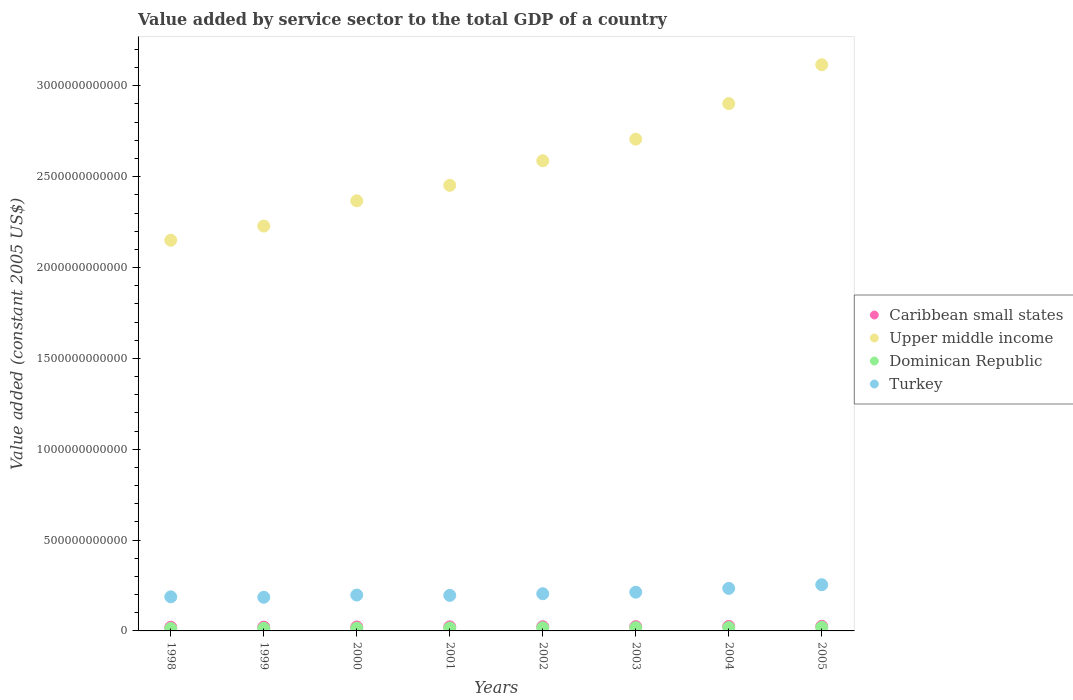How many different coloured dotlines are there?
Your answer should be very brief. 4. Is the number of dotlines equal to the number of legend labels?
Make the answer very short. Yes. What is the value added by service sector in Dominican Republic in 2004?
Your response must be concise. 1.81e+1. Across all years, what is the maximum value added by service sector in Dominican Republic?
Offer a very short reply. 1.97e+1. Across all years, what is the minimum value added by service sector in Upper middle income?
Your response must be concise. 2.15e+12. What is the total value added by service sector in Caribbean small states in the graph?
Make the answer very short. 1.82e+11. What is the difference between the value added by service sector in Turkey in 2001 and that in 2003?
Give a very brief answer. -1.76e+1. What is the difference between the value added by service sector in Upper middle income in 2005 and the value added by service sector in Turkey in 2000?
Provide a succinct answer. 2.92e+12. What is the average value added by service sector in Dominican Republic per year?
Give a very brief answer. 1.63e+1. In the year 2002, what is the difference between the value added by service sector in Turkey and value added by service sector in Upper middle income?
Keep it short and to the point. -2.38e+12. In how many years, is the value added by service sector in Dominican Republic greater than 2500000000000 US$?
Provide a short and direct response. 0. What is the ratio of the value added by service sector in Dominican Republic in 2000 to that in 2004?
Ensure brevity in your answer.  0.82. Is the value added by service sector in Turkey in 1998 less than that in 1999?
Make the answer very short. No. What is the difference between the highest and the second highest value added by service sector in Upper middle income?
Keep it short and to the point. 2.14e+11. What is the difference between the highest and the lowest value added by service sector in Turkey?
Give a very brief answer. 6.90e+1. Is the sum of the value added by service sector in Dominican Republic in 2000 and 2003 greater than the maximum value added by service sector in Turkey across all years?
Your answer should be compact. No. Is it the case that in every year, the sum of the value added by service sector in Dominican Republic and value added by service sector in Turkey  is greater than the value added by service sector in Caribbean small states?
Your response must be concise. Yes. Is the value added by service sector in Dominican Republic strictly greater than the value added by service sector in Caribbean small states over the years?
Your response must be concise. No. Is the value added by service sector in Turkey strictly less than the value added by service sector in Dominican Republic over the years?
Provide a short and direct response. No. What is the difference between two consecutive major ticks on the Y-axis?
Your answer should be compact. 5.00e+11. Are the values on the major ticks of Y-axis written in scientific E-notation?
Ensure brevity in your answer.  No. Does the graph contain any zero values?
Make the answer very short. No. How are the legend labels stacked?
Your answer should be very brief. Vertical. What is the title of the graph?
Offer a very short reply. Value added by service sector to the total GDP of a country. What is the label or title of the Y-axis?
Offer a terse response. Value added (constant 2005 US$). What is the Value added (constant 2005 US$) in Caribbean small states in 1998?
Offer a terse response. 2.03e+1. What is the Value added (constant 2005 US$) in Upper middle income in 1998?
Offer a very short reply. 2.15e+12. What is the Value added (constant 2005 US$) in Dominican Republic in 1998?
Make the answer very short. 1.33e+1. What is the Value added (constant 2005 US$) in Turkey in 1998?
Provide a succinct answer. 1.88e+11. What is the Value added (constant 2005 US$) of Caribbean small states in 1999?
Make the answer very short. 2.11e+1. What is the Value added (constant 2005 US$) of Upper middle income in 1999?
Make the answer very short. 2.23e+12. What is the Value added (constant 2005 US$) in Dominican Republic in 1999?
Keep it short and to the point. 1.42e+1. What is the Value added (constant 2005 US$) in Turkey in 1999?
Offer a terse response. 1.85e+11. What is the Value added (constant 2005 US$) in Caribbean small states in 2000?
Offer a terse response. 2.18e+1. What is the Value added (constant 2005 US$) of Upper middle income in 2000?
Make the answer very short. 2.37e+12. What is the Value added (constant 2005 US$) of Dominican Republic in 2000?
Provide a short and direct response. 1.49e+1. What is the Value added (constant 2005 US$) in Turkey in 2000?
Offer a very short reply. 1.97e+11. What is the Value added (constant 2005 US$) of Caribbean small states in 2001?
Offer a terse response. 2.23e+1. What is the Value added (constant 2005 US$) in Upper middle income in 2001?
Offer a very short reply. 2.45e+12. What is the Value added (constant 2005 US$) in Dominican Republic in 2001?
Keep it short and to the point. 1.58e+1. What is the Value added (constant 2005 US$) in Turkey in 2001?
Ensure brevity in your answer.  1.96e+11. What is the Value added (constant 2005 US$) in Caribbean small states in 2002?
Your answer should be compact. 2.31e+1. What is the Value added (constant 2005 US$) of Upper middle income in 2002?
Keep it short and to the point. 2.59e+12. What is the Value added (constant 2005 US$) in Dominican Republic in 2002?
Your answer should be very brief. 1.70e+1. What is the Value added (constant 2005 US$) in Turkey in 2002?
Give a very brief answer. 2.05e+11. What is the Value added (constant 2005 US$) in Caribbean small states in 2003?
Offer a terse response. 2.36e+1. What is the Value added (constant 2005 US$) in Upper middle income in 2003?
Your response must be concise. 2.71e+12. What is the Value added (constant 2005 US$) in Dominican Republic in 2003?
Keep it short and to the point. 1.77e+1. What is the Value added (constant 2005 US$) in Turkey in 2003?
Provide a short and direct response. 2.13e+11. What is the Value added (constant 2005 US$) of Caribbean small states in 2004?
Your response must be concise. 2.48e+1. What is the Value added (constant 2005 US$) in Upper middle income in 2004?
Ensure brevity in your answer.  2.90e+12. What is the Value added (constant 2005 US$) in Dominican Republic in 2004?
Provide a short and direct response. 1.81e+1. What is the Value added (constant 2005 US$) in Turkey in 2004?
Provide a short and direct response. 2.34e+11. What is the Value added (constant 2005 US$) in Caribbean small states in 2005?
Your answer should be compact. 2.53e+1. What is the Value added (constant 2005 US$) in Upper middle income in 2005?
Make the answer very short. 3.12e+12. What is the Value added (constant 2005 US$) of Dominican Republic in 2005?
Give a very brief answer. 1.97e+1. What is the Value added (constant 2005 US$) in Turkey in 2005?
Your answer should be compact. 2.54e+11. Across all years, what is the maximum Value added (constant 2005 US$) of Caribbean small states?
Offer a very short reply. 2.53e+1. Across all years, what is the maximum Value added (constant 2005 US$) in Upper middle income?
Ensure brevity in your answer.  3.12e+12. Across all years, what is the maximum Value added (constant 2005 US$) of Dominican Republic?
Your answer should be compact. 1.97e+1. Across all years, what is the maximum Value added (constant 2005 US$) in Turkey?
Ensure brevity in your answer.  2.54e+11. Across all years, what is the minimum Value added (constant 2005 US$) in Caribbean small states?
Your response must be concise. 2.03e+1. Across all years, what is the minimum Value added (constant 2005 US$) in Upper middle income?
Give a very brief answer. 2.15e+12. Across all years, what is the minimum Value added (constant 2005 US$) of Dominican Republic?
Provide a succinct answer. 1.33e+1. Across all years, what is the minimum Value added (constant 2005 US$) in Turkey?
Make the answer very short. 1.85e+11. What is the total Value added (constant 2005 US$) in Caribbean small states in the graph?
Your answer should be compact. 1.82e+11. What is the total Value added (constant 2005 US$) in Upper middle income in the graph?
Keep it short and to the point. 2.05e+13. What is the total Value added (constant 2005 US$) of Dominican Republic in the graph?
Ensure brevity in your answer.  1.31e+11. What is the total Value added (constant 2005 US$) of Turkey in the graph?
Give a very brief answer. 1.67e+12. What is the difference between the Value added (constant 2005 US$) of Caribbean small states in 1998 and that in 1999?
Provide a short and direct response. -8.02e+08. What is the difference between the Value added (constant 2005 US$) of Upper middle income in 1998 and that in 1999?
Provide a short and direct response. -7.80e+1. What is the difference between the Value added (constant 2005 US$) of Dominican Republic in 1998 and that in 1999?
Give a very brief answer. -8.99e+08. What is the difference between the Value added (constant 2005 US$) of Turkey in 1998 and that in 1999?
Provide a short and direct response. 2.40e+09. What is the difference between the Value added (constant 2005 US$) in Caribbean small states in 1998 and that in 2000?
Give a very brief answer. -1.56e+09. What is the difference between the Value added (constant 2005 US$) of Upper middle income in 1998 and that in 2000?
Ensure brevity in your answer.  -2.17e+11. What is the difference between the Value added (constant 2005 US$) of Dominican Republic in 1998 and that in 2000?
Offer a very short reply. -1.66e+09. What is the difference between the Value added (constant 2005 US$) of Turkey in 1998 and that in 2000?
Provide a short and direct response. -9.85e+09. What is the difference between the Value added (constant 2005 US$) in Caribbean small states in 1998 and that in 2001?
Offer a very short reply. -2.09e+09. What is the difference between the Value added (constant 2005 US$) in Upper middle income in 1998 and that in 2001?
Provide a succinct answer. -3.02e+11. What is the difference between the Value added (constant 2005 US$) in Dominican Republic in 1998 and that in 2001?
Your answer should be very brief. -2.53e+09. What is the difference between the Value added (constant 2005 US$) in Turkey in 1998 and that in 2001?
Make the answer very short. -7.94e+09. What is the difference between the Value added (constant 2005 US$) of Caribbean small states in 1998 and that in 2002?
Give a very brief answer. -2.87e+09. What is the difference between the Value added (constant 2005 US$) in Upper middle income in 1998 and that in 2002?
Keep it short and to the point. -4.37e+11. What is the difference between the Value added (constant 2005 US$) of Dominican Republic in 1998 and that in 2002?
Provide a short and direct response. -3.71e+09. What is the difference between the Value added (constant 2005 US$) of Turkey in 1998 and that in 2002?
Provide a succinct answer. -1.71e+1. What is the difference between the Value added (constant 2005 US$) in Caribbean small states in 1998 and that in 2003?
Ensure brevity in your answer.  -3.31e+09. What is the difference between the Value added (constant 2005 US$) in Upper middle income in 1998 and that in 2003?
Offer a very short reply. -5.56e+11. What is the difference between the Value added (constant 2005 US$) of Dominican Republic in 1998 and that in 2003?
Provide a short and direct response. -4.40e+09. What is the difference between the Value added (constant 2005 US$) of Turkey in 1998 and that in 2003?
Your response must be concise. -2.55e+1. What is the difference between the Value added (constant 2005 US$) in Caribbean small states in 1998 and that in 2004?
Your response must be concise. -4.55e+09. What is the difference between the Value added (constant 2005 US$) in Upper middle income in 1998 and that in 2004?
Your answer should be very brief. -7.52e+11. What is the difference between the Value added (constant 2005 US$) in Dominican Republic in 1998 and that in 2004?
Your response must be concise. -4.88e+09. What is the difference between the Value added (constant 2005 US$) of Turkey in 1998 and that in 2004?
Your response must be concise. -4.65e+1. What is the difference between the Value added (constant 2005 US$) of Caribbean small states in 1998 and that in 2005?
Make the answer very short. -5.08e+09. What is the difference between the Value added (constant 2005 US$) in Upper middle income in 1998 and that in 2005?
Your answer should be compact. -9.66e+11. What is the difference between the Value added (constant 2005 US$) in Dominican Republic in 1998 and that in 2005?
Make the answer very short. -6.48e+09. What is the difference between the Value added (constant 2005 US$) of Turkey in 1998 and that in 2005?
Provide a succinct answer. -6.66e+1. What is the difference between the Value added (constant 2005 US$) of Caribbean small states in 1999 and that in 2000?
Make the answer very short. -7.59e+08. What is the difference between the Value added (constant 2005 US$) in Upper middle income in 1999 and that in 2000?
Offer a very short reply. -1.39e+11. What is the difference between the Value added (constant 2005 US$) of Dominican Republic in 1999 and that in 2000?
Ensure brevity in your answer.  -7.59e+08. What is the difference between the Value added (constant 2005 US$) of Turkey in 1999 and that in 2000?
Provide a short and direct response. -1.22e+1. What is the difference between the Value added (constant 2005 US$) in Caribbean small states in 1999 and that in 2001?
Provide a succinct answer. -1.29e+09. What is the difference between the Value added (constant 2005 US$) in Upper middle income in 1999 and that in 2001?
Ensure brevity in your answer.  -2.24e+11. What is the difference between the Value added (constant 2005 US$) in Dominican Republic in 1999 and that in 2001?
Ensure brevity in your answer.  -1.64e+09. What is the difference between the Value added (constant 2005 US$) of Turkey in 1999 and that in 2001?
Give a very brief answer. -1.03e+1. What is the difference between the Value added (constant 2005 US$) in Caribbean small states in 1999 and that in 2002?
Your answer should be very brief. -2.07e+09. What is the difference between the Value added (constant 2005 US$) in Upper middle income in 1999 and that in 2002?
Your response must be concise. -3.59e+11. What is the difference between the Value added (constant 2005 US$) of Dominican Republic in 1999 and that in 2002?
Offer a very short reply. -2.81e+09. What is the difference between the Value added (constant 2005 US$) in Turkey in 1999 and that in 2002?
Make the answer very short. -1.95e+1. What is the difference between the Value added (constant 2005 US$) of Caribbean small states in 1999 and that in 2003?
Provide a succinct answer. -2.51e+09. What is the difference between the Value added (constant 2005 US$) in Upper middle income in 1999 and that in 2003?
Your answer should be compact. -4.78e+11. What is the difference between the Value added (constant 2005 US$) of Dominican Republic in 1999 and that in 2003?
Offer a very short reply. -3.50e+09. What is the difference between the Value added (constant 2005 US$) in Turkey in 1999 and that in 2003?
Ensure brevity in your answer.  -2.79e+1. What is the difference between the Value added (constant 2005 US$) of Caribbean small states in 1999 and that in 2004?
Offer a very short reply. -3.75e+09. What is the difference between the Value added (constant 2005 US$) of Upper middle income in 1999 and that in 2004?
Your answer should be very brief. -6.74e+11. What is the difference between the Value added (constant 2005 US$) in Dominican Republic in 1999 and that in 2004?
Keep it short and to the point. -3.98e+09. What is the difference between the Value added (constant 2005 US$) of Turkey in 1999 and that in 2004?
Your response must be concise. -4.89e+1. What is the difference between the Value added (constant 2005 US$) in Caribbean small states in 1999 and that in 2005?
Your response must be concise. -4.28e+09. What is the difference between the Value added (constant 2005 US$) in Upper middle income in 1999 and that in 2005?
Provide a short and direct response. -8.88e+11. What is the difference between the Value added (constant 2005 US$) in Dominican Republic in 1999 and that in 2005?
Offer a terse response. -5.58e+09. What is the difference between the Value added (constant 2005 US$) of Turkey in 1999 and that in 2005?
Offer a very short reply. -6.90e+1. What is the difference between the Value added (constant 2005 US$) in Caribbean small states in 2000 and that in 2001?
Make the answer very short. -5.29e+08. What is the difference between the Value added (constant 2005 US$) of Upper middle income in 2000 and that in 2001?
Make the answer very short. -8.53e+1. What is the difference between the Value added (constant 2005 US$) of Dominican Republic in 2000 and that in 2001?
Provide a short and direct response. -8.76e+08. What is the difference between the Value added (constant 2005 US$) of Turkey in 2000 and that in 2001?
Keep it short and to the point. 1.90e+09. What is the difference between the Value added (constant 2005 US$) of Caribbean small states in 2000 and that in 2002?
Ensure brevity in your answer.  -1.31e+09. What is the difference between the Value added (constant 2005 US$) of Upper middle income in 2000 and that in 2002?
Offer a terse response. -2.21e+11. What is the difference between the Value added (constant 2005 US$) of Dominican Republic in 2000 and that in 2002?
Offer a very short reply. -2.06e+09. What is the difference between the Value added (constant 2005 US$) of Turkey in 2000 and that in 2002?
Make the answer very short. -7.24e+09. What is the difference between the Value added (constant 2005 US$) in Caribbean small states in 2000 and that in 2003?
Provide a short and direct response. -1.75e+09. What is the difference between the Value added (constant 2005 US$) of Upper middle income in 2000 and that in 2003?
Offer a terse response. -3.39e+11. What is the difference between the Value added (constant 2005 US$) of Dominican Republic in 2000 and that in 2003?
Provide a short and direct response. -2.74e+09. What is the difference between the Value added (constant 2005 US$) in Turkey in 2000 and that in 2003?
Keep it short and to the point. -1.57e+1. What is the difference between the Value added (constant 2005 US$) in Caribbean small states in 2000 and that in 2004?
Offer a terse response. -2.99e+09. What is the difference between the Value added (constant 2005 US$) in Upper middle income in 2000 and that in 2004?
Give a very brief answer. -5.35e+11. What is the difference between the Value added (constant 2005 US$) of Dominican Republic in 2000 and that in 2004?
Ensure brevity in your answer.  -3.22e+09. What is the difference between the Value added (constant 2005 US$) of Turkey in 2000 and that in 2004?
Provide a short and direct response. -3.67e+1. What is the difference between the Value added (constant 2005 US$) of Caribbean small states in 2000 and that in 2005?
Provide a succinct answer. -3.52e+09. What is the difference between the Value added (constant 2005 US$) of Upper middle income in 2000 and that in 2005?
Make the answer very short. -7.49e+11. What is the difference between the Value added (constant 2005 US$) in Dominican Republic in 2000 and that in 2005?
Provide a short and direct response. -4.82e+09. What is the difference between the Value added (constant 2005 US$) of Turkey in 2000 and that in 2005?
Your response must be concise. -5.68e+1. What is the difference between the Value added (constant 2005 US$) in Caribbean small states in 2001 and that in 2002?
Provide a short and direct response. -7.84e+08. What is the difference between the Value added (constant 2005 US$) of Upper middle income in 2001 and that in 2002?
Make the answer very short. -1.35e+11. What is the difference between the Value added (constant 2005 US$) in Dominican Republic in 2001 and that in 2002?
Offer a terse response. -1.18e+09. What is the difference between the Value added (constant 2005 US$) of Turkey in 2001 and that in 2002?
Keep it short and to the point. -9.14e+09. What is the difference between the Value added (constant 2005 US$) of Caribbean small states in 2001 and that in 2003?
Offer a very short reply. -1.22e+09. What is the difference between the Value added (constant 2005 US$) in Upper middle income in 2001 and that in 2003?
Provide a succinct answer. -2.54e+11. What is the difference between the Value added (constant 2005 US$) of Dominican Republic in 2001 and that in 2003?
Your answer should be very brief. -1.86e+09. What is the difference between the Value added (constant 2005 US$) of Turkey in 2001 and that in 2003?
Your answer should be compact. -1.76e+1. What is the difference between the Value added (constant 2005 US$) of Caribbean small states in 2001 and that in 2004?
Offer a terse response. -2.46e+09. What is the difference between the Value added (constant 2005 US$) in Upper middle income in 2001 and that in 2004?
Provide a short and direct response. -4.50e+11. What is the difference between the Value added (constant 2005 US$) of Dominican Republic in 2001 and that in 2004?
Make the answer very short. -2.34e+09. What is the difference between the Value added (constant 2005 US$) of Turkey in 2001 and that in 2004?
Give a very brief answer. -3.86e+1. What is the difference between the Value added (constant 2005 US$) in Caribbean small states in 2001 and that in 2005?
Offer a very short reply. -3.00e+09. What is the difference between the Value added (constant 2005 US$) of Upper middle income in 2001 and that in 2005?
Offer a terse response. -6.64e+11. What is the difference between the Value added (constant 2005 US$) of Dominican Republic in 2001 and that in 2005?
Make the answer very short. -3.94e+09. What is the difference between the Value added (constant 2005 US$) of Turkey in 2001 and that in 2005?
Provide a succinct answer. -5.87e+1. What is the difference between the Value added (constant 2005 US$) of Caribbean small states in 2002 and that in 2003?
Your answer should be very brief. -4.38e+08. What is the difference between the Value added (constant 2005 US$) of Upper middle income in 2002 and that in 2003?
Your answer should be compact. -1.19e+11. What is the difference between the Value added (constant 2005 US$) of Dominican Republic in 2002 and that in 2003?
Make the answer very short. -6.85e+08. What is the difference between the Value added (constant 2005 US$) in Turkey in 2002 and that in 2003?
Your answer should be very brief. -8.46e+09. What is the difference between the Value added (constant 2005 US$) in Caribbean small states in 2002 and that in 2004?
Give a very brief answer. -1.68e+09. What is the difference between the Value added (constant 2005 US$) of Upper middle income in 2002 and that in 2004?
Ensure brevity in your answer.  -3.15e+11. What is the difference between the Value added (constant 2005 US$) of Dominican Republic in 2002 and that in 2004?
Your answer should be very brief. -1.16e+09. What is the difference between the Value added (constant 2005 US$) in Turkey in 2002 and that in 2004?
Ensure brevity in your answer.  -2.94e+1. What is the difference between the Value added (constant 2005 US$) of Caribbean small states in 2002 and that in 2005?
Give a very brief answer. -2.21e+09. What is the difference between the Value added (constant 2005 US$) of Upper middle income in 2002 and that in 2005?
Ensure brevity in your answer.  -5.28e+11. What is the difference between the Value added (constant 2005 US$) of Dominican Republic in 2002 and that in 2005?
Provide a short and direct response. -2.76e+09. What is the difference between the Value added (constant 2005 US$) of Turkey in 2002 and that in 2005?
Keep it short and to the point. -4.95e+1. What is the difference between the Value added (constant 2005 US$) of Caribbean small states in 2003 and that in 2004?
Your response must be concise. -1.24e+09. What is the difference between the Value added (constant 2005 US$) of Upper middle income in 2003 and that in 2004?
Make the answer very short. -1.96e+11. What is the difference between the Value added (constant 2005 US$) in Dominican Republic in 2003 and that in 2004?
Keep it short and to the point. -4.76e+08. What is the difference between the Value added (constant 2005 US$) in Turkey in 2003 and that in 2004?
Your answer should be very brief. -2.10e+1. What is the difference between the Value added (constant 2005 US$) of Caribbean small states in 2003 and that in 2005?
Offer a terse response. -1.77e+09. What is the difference between the Value added (constant 2005 US$) of Upper middle income in 2003 and that in 2005?
Ensure brevity in your answer.  -4.09e+11. What is the difference between the Value added (constant 2005 US$) in Dominican Republic in 2003 and that in 2005?
Ensure brevity in your answer.  -2.08e+09. What is the difference between the Value added (constant 2005 US$) of Turkey in 2003 and that in 2005?
Your response must be concise. -4.11e+1. What is the difference between the Value added (constant 2005 US$) in Caribbean small states in 2004 and that in 2005?
Provide a short and direct response. -5.33e+08. What is the difference between the Value added (constant 2005 US$) in Upper middle income in 2004 and that in 2005?
Your answer should be compact. -2.14e+11. What is the difference between the Value added (constant 2005 US$) of Dominican Republic in 2004 and that in 2005?
Offer a terse response. -1.60e+09. What is the difference between the Value added (constant 2005 US$) in Turkey in 2004 and that in 2005?
Your response must be concise. -2.01e+1. What is the difference between the Value added (constant 2005 US$) in Caribbean small states in 1998 and the Value added (constant 2005 US$) in Upper middle income in 1999?
Offer a very short reply. -2.21e+12. What is the difference between the Value added (constant 2005 US$) in Caribbean small states in 1998 and the Value added (constant 2005 US$) in Dominican Republic in 1999?
Ensure brevity in your answer.  6.09e+09. What is the difference between the Value added (constant 2005 US$) of Caribbean small states in 1998 and the Value added (constant 2005 US$) of Turkey in 1999?
Offer a very short reply. -1.65e+11. What is the difference between the Value added (constant 2005 US$) of Upper middle income in 1998 and the Value added (constant 2005 US$) of Dominican Republic in 1999?
Provide a succinct answer. 2.14e+12. What is the difference between the Value added (constant 2005 US$) in Upper middle income in 1998 and the Value added (constant 2005 US$) in Turkey in 1999?
Make the answer very short. 1.96e+12. What is the difference between the Value added (constant 2005 US$) in Dominican Republic in 1998 and the Value added (constant 2005 US$) in Turkey in 1999?
Ensure brevity in your answer.  -1.72e+11. What is the difference between the Value added (constant 2005 US$) in Caribbean small states in 1998 and the Value added (constant 2005 US$) in Upper middle income in 2000?
Make the answer very short. -2.35e+12. What is the difference between the Value added (constant 2005 US$) of Caribbean small states in 1998 and the Value added (constant 2005 US$) of Dominican Republic in 2000?
Provide a short and direct response. 5.33e+09. What is the difference between the Value added (constant 2005 US$) of Caribbean small states in 1998 and the Value added (constant 2005 US$) of Turkey in 2000?
Ensure brevity in your answer.  -1.77e+11. What is the difference between the Value added (constant 2005 US$) in Upper middle income in 1998 and the Value added (constant 2005 US$) in Dominican Republic in 2000?
Keep it short and to the point. 2.14e+12. What is the difference between the Value added (constant 2005 US$) in Upper middle income in 1998 and the Value added (constant 2005 US$) in Turkey in 2000?
Give a very brief answer. 1.95e+12. What is the difference between the Value added (constant 2005 US$) of Dominican Republic in 1998 and the Value added (constant 2005 US$) of Turkey in 2000?
Provide a succinct answer. -1.84e+11. What is the difference between the Value added (constant 2005 US$) in Caribbean small states in 1998 and the Value added (constant 2005 US$) in Upper middle income in 2001?
Keep it short and to the point. -2.43e+12. What is the difference between the Value added (constant 2005 US$) in Caribbean small states in 1998 and the Value added (constant 2005 US$) in Dominican Republic in 2001?
Ensure brevity in your answer.  4.45e+09. What is the difference between the Value added (constant 2005 US$) of Caribbean small states in 1998 and the Value added (constant 2005 US$) of Turkey in 2001?
Your response must be concise. -1.75e+11. What is the difference between the Value added (constant 2005 US$) of Upper middle income in 1998 and the Value added (constant 2005 US$) of Dominican Republic in 2001?
Make the answer very short. 2.13e+12. What is the difference between the Value added (constant 2005 US$) in Upper middle income in 1998 and the Value added (constant 2005 US$) in Turkey in 2001?
Offer a very short reply. 1.95e+12. What is the difference between the Value added (constant 2005 US$) in Dominican Republic in 1998 and the Value added (constant 2005 US$) in Turkey in 2001?
Your response must be concise. -1.82e+11. What is the difference between the Value added (constant 2005 US$) in Caribbean small states in 1998 and the Value added (constant 2005 US$) in Upper middle income in 2002?
Make the answer very short. -2.57e+12. What is the difference between the Value added (constant 2005 US$) of Caribbean small states in 1998 and the Value added (constant 2005 US$) of Dominican Republic in 2002?
Your answer should be compact. 3.27e+09. What is the difference between the Value added (constant 2005 US$) of Caribbean small states in 1998 and the Value added (constant 2005 US$) of Turkey in 2002?
Offer a terse response. -1.84e+11. What is the difference between the Value added (constant 2005 US$) of Upper middle income in 1998 and the Value added (constant 2005 US$) of Dominican Republic in 2002?
Offer a very short reply. 2.13e+12. What is the difference between the Value added (constant 2005 US$) in Upper middle income in 1998 and the Value added (constant 2005 US$) in Turkey in 2002?
Your answer should be very brief. 1.95e+12. What is the difference between the Value added (constant 2005 US$) in Dominican Republic in 1998 and the Value added (constant 2005 US$) in Turkey in 2002?
Make the answer very short. -1.91e+11. What is the difference between the Value added (constant 2005 US$) of Caribbean small states in 1998 and the Value added (constant 2005 US$) of Upper middle income in 2003?
Keep it short and to the point. -2.69e+12. What is the difference between the Value added (constant 2005 US$) in Caribbean small states in 1998 and the Value added (constant 2005 US$) in Dominican Republic in 2003?
Keep it short and to the point. 2.59e+09. What is the difference between the Value added (constant 2005 US$) in Caribbean small states in 1998 and the Value added (constant 2005 US$) in Turkey in 2003?
Keep it short and to the point. -1.93e+11. What is the difference between the Value added (constant 2005 US$) in Upper middle income in 1998 and the Value added (constant 2005 US$) in Dominican Republic in 2003?
Give a very brief answer. 2.13e+12. What is the difference between the Value added (constant 2005 US$) of Upper middle income in 1998 and the Value added (constant 2005 US$) of Turkey in 2003?
Offer a very short reply. 1.94e+12. What is the difference between the Value added (constant 2005 US$) of Dominican Republic in 1998 and the Value added (constant 2005 US$) of Turkey in 2003?
Give a very brief answer. -2.00e+11. What is the difference between the Value added (constant 2005 US$) in Caribbean small states in 1998 and the Value added (constant 2005 US$) in Upper middle income in 2004?
Provide a succinct answer. -2.88e+12. What is the difference between the Value added (constant 2005 US$) in Caribbean small states in 1998 and the Value added (constant 2005 US$) in Dominican Republic in 2004?
Offer a very short reply. 2.11e+09. What is the difference between the Value added (constant 2005 US$) in Caribbean small states in 1998 and the Value added (constant 2005 US$) in Turkey in 2004?
Offer a terse response. -2.14e+11. What is the difference between the Value added (constant 2005 US$) in Upper middle income in 1998 and the Value added (constant 2005 US$) in Dominican Republic in 2004?
Offer a very short reply. 2.13e+12. What is the difference between the Value added (constant 2005 US$) in Upper middle income in 1998 and the Value added (constant 2005 US$) in Turkey in 2004?
Ensure brevity in your answer.  1.92e+12. What is the difference between the Value added (constant 2005 US$) of Dominican Republic in 1998 and the Value added (constant 2005 US$) of Turkey in 2004?
Provide a short and direct response. -2.21e+11. What is the difference between the Value added (constant 2005 US$) of Caribbean small states in 1998 and the Value added (constant 2005 US$) of Upper middle income in 2005?
Provide a short and direct response. -3.10e+12. What is the difference between the Value added (constant 2005 US$) in Caribbean small states in 1998 and the Value added (constant 2005 US$) in Dominican Republic in 2005?
Your response must be concise. 5.11e+08. What is the difference between the Value added (constant 2005 US$) in Caribbean small states in 1998 and the Value added (constant 2005 US$) in Turkey in 2005?
Ensure brevity in your answer.  -2.34e+11. What is the difference between the Value added (constant 2005 US$) in Upper middle income in 1998 and the Value added (constant 2005 US$) in Dominican Republic in 2005?
Make the answer very short. 2.13e+12. What is the difference between the Value added (constant 2005 US$) in Upper middle income in 1998 and the Value added (constant 2005 US$) in Turkey in 2005?
Provide a succinct answer. 1.90e+12. What is the difference between the Value added (constant 2005 US$) of Dominican Republic in 1998 and the Value added (constant 2005 US$) of Turkey in 2005?
Your answer should be very brief. -2.41e+11. What is the difference between the Value added (constant 2005 US$) of Caribbean small states in 1999 and the Value added (constant 2005 US$) of Upper middle income in 2000?
Your answer should be compact. -2.35e+12. What is the difference between the Value added (constant 2005 US$) of Caribbean small states in 1999 and the Value added (constant 2005 US$) of Dominican Republic in 2000?
Keep it short and to the point. 6.13e+09. What is the difference between the Value added (constant 2005 US$) of Caribbean small states in 1999 and the Value added (constant 2005 US$) of Turkey in 2000?
Give a very brief answer. -1.76e+11. What is the difference between the Value added (constant 2005 US$) in Upper middle income in 1999 and the Value added (constant 2005 US$) in Dominican Republic in 2000?
Keep it short and to the point. 2.21e+12. What is the difference between the Value added (constant 2005 US$) of Upper middle income in 1999 and the Value added (constant 2005 US$) of Turkey in 2000?
Give a very brief answer. 2.03e+12. What is the difference between the Value added (constant 2005 US$) of Dominican Republic in 1999 and the Value added (constant 2005 US$) of Turkey in 2000?
Keep it short and to the point. -1.83e+11. What is the difference between the Value added (constant 2005 US$) in Caribbean small states in 1999 and the Value added (constant 2005 US$) in Upper middle income in 2001?
Keep it short and to the point. -2.43e+12. What is the difference between the Value added (constant 2005 US$) of Caribbean small states in 1999 and the Value added (constant 2005 US$) of Dominican Republic in 2001?
Your response must be concise. 5.26e+09. What is the difference between the Value added (constant 2005 US$) of Caribbean small states in 1999 and the Value added (constant 2005 US$) of Turkey in 2001?
Provide a succinct answer. -1.75e+11. What is the difference between the Value added (constant 2005 US$) in Upper middle income in 1999 and the Value added (constant 2005 US$) in Dominican Republic in 2001?
Your response must be concise. 2.21e+12. What is the difference between the Value added (constant 2005 US$) in Upper middle income in 1999 and the Value added (constant 2005 US$) in Turkey in 2001?
Provide a short and direct response. 2.03e+12. What is the difference between the Value added (constant 2005 US$) of Dominican Republic in 1999 and the Value added (constant 2005 US$) of Turkey in 2001?
Offer a terse response. -1.81e+11. What is the difference between the Value added (constant 2005 US$) in Caribbean small states in 1999 and the Value added (constant 2005 US$) in Upper middle income in 2002?
Offer a terse response. -2.57e+12. What is the difference between the Value added (constant 2005 US$) of Caribbean small states in 1999 and the Value added (constant 2005 US$) of Dominican Republic in 2002?
Ensure brevity in your answer.  4.08e+09. What is the difference between the Value added (constant 2005 US$) of Caribbean small states in 1999 and the Value added (constant 2005 US$) of Turkey in 2002?
Your answer should be compact. -1.84e+11. What is the difference between the Value added (constant 2005 US$) in Upper middle income in 1999 and the Value added (constant 2005 US$) in Dominican Republic in 2002?
Your response must be concise. 2.21e+12. What is the difference between the Value added (constant 2005 US$) in Upper middle income in 1999 and the Value added (constant 2005 US$) in Turkey in 2002?
Offer a terse response. 2.02e+12. What is the difference between the Value added (constant 2005 US$) in Dominican Republic in 1999 and the Value added (constant 2005 US$) in Turkey in 2002?
Keep it short and to the point. -1.91e+11. What is the difference between the Value added (constant 2005 US$) of Caribbean small states in 1999 and the Value added (constant 2005 US$) of Upper middle income in 2003?
Your answer should be compact. -2.69e+12. What is the difference between the Value added (constant 2005 US$) of Caribbean small states in 1999 and the Value added (constant 2005 US$) of Dominican Republic in 2003?
Give a very brief answer. 3.39e+09. What is the difference between the Value added (constant 2005 US$) of Caribbean small states in 1999 and the Value added (constant 2005 US$) of Turkey in 2003?
Give a very brief answer. -1.92e+11. What is the difference between the Value added (constant 2005 US$) of Upper middle income in 1999 and the Value added (constant 2005 US$) of Dominican Republic in 2003?
Your response must be concise. 2.21e+12. What is the difference between the Value added (constant 2005 US$) of Upper middle income in 1999 and the Value added (constant 2005 US$) of Turkey in 2003?
Your answer should be very brief. 2.02e+12. What is the difference between the Value added (constant 2005 US$) of Dominican Republic in 1999 and the Value added (constant 2005 US$) of Turkey in 2003?
Keep it short and to the point. -1.99e+11. What is the difference between the Value added (constant 2005 US$) of Caribbean small states in 1999 and the Value added (constant 2005 US$) of Upper middle income in 2004?
Your answer should be very brief. -2.88e+12. What is the difference between the Value added (constant 2005 US$) of Caribbean small states in 1999 and the Value added (constant 2005 US$) of Dominican Republic in 2004?
Keep it short and to the point. 2.92e+09. What is the difference between the Value added (constant 2005 US$) of Caribbean small states in 1999 and the Value added (constant 2005 US$) of Turkey in 2004?
Provide a succinct answer. -2.13e+11. What is the difference between the Value added (constant 2005 US$) in Upper middle income in 1999 and the Value added (constant 2005 US$) in Dominican Republic in 2004?
Give a very brief answer. 2.21e+12. What is the difference between the Value added (constant 2005 US$) of Upper middle income in 1999 and the Value added (constant 2005 US$) of Turkey in 2004?
Offer a terse response. 1.99e+12. What is the difference between the Value added (constant 2005 US$) of Dominican Republic in 1999 and the Value added (constant 2005 US$) of Turkey in 2004?
Provide a short and direct response. -2.20e+11. What is the difference between the Value added (constant 2005 US$) of Caribbean small states in 1999 and the Value added (constant 2005 US$) of Upper middle income in 2005?
Keep it short and to the point. -3.09e+12. What is the difference between the Value added (constant 2005 US$) in Caribbean small states in 1999 and the Value added (constant 2005 US$) in Dominican Republic in 2005?
Your answer should be very brief. 1.31e+09. What is the difference between the Value added (constant 2005 US$) of Caribbean small states in 1999 and the Value added (constant 2005 US$) of Turkey in 2005?
Provide a short and direct response. -2.33e+11. What is the difference between the Value added (constant 2005 US$) of Upper middle income in 1999 and the Value added (constant 2005 US$) of Dominican Republic in 2005?
Offer a terse response. 2.21e+12. What is the difference between the Value added (constant 2005 US$) of Upper middle income in 1999 and the Value added (constant 2005 US$) of Turkey in 2005?
Make the answer very short. 1.97e+12. What is the difference between the Value added (constant 2005 US$) in Dominican Republic in 1999 and the Value added (constant 2005 US$) in Turkey in 2005?
Your answer should be compact. -2.40e+11. What is the difference between the Value added (constant 2005 US$) of Caribbean small states in 2000 and the Value added (constant 2005 US$) of Upper middle income in 2001?
Your answer should be very brief. -2.43e+12. What is the difference between the Value added (constant 2005 US$) of Caribbean small states in 2000 and the Value added (constant 2005 US$) of Dominican Republic in 2001?
Ensure brevity in your answer.  6.01e+09. What is the difference between the Value added (constant 2005 US$) of Caribbean small states in 2000 and the Value added (constant 2005 US$) of Turkey in 2001?
Offer a terse response. -1.74e+11. What is the difference between the Value added (constant 2005 US$) in Upper middle income in 2000 and the Value added (constant 2005 US$) in Dominican Republic in 2001?
Your answer should be compact. 2.35e+12. What is the difference between the Value added (constant 2005 US$) in Upper middle income in 2000 and the Value added (constant 2005 US$) in Turkey in 2001?
Your answer should be very brief. 2.17e+12. What is the difference between the Value added (constant 2005 US$) in Dominican Republic in 2000 and the Value added (constant 2005 US$) in Turkey in 2001?
Provide a short and direct response. -1.81e+11. What is the difference between the Value added (constant 2005 US$) of Caribbean small states in 2000 and the Value added (constant 2005 US$) of Upper middle income in 2002?
Keep it short and to the point. -2.57e+12. What is the difference between the Value added (constant 2005 US$) in Caribbean small states in 2000 and the Value added (constant 2005 US$) in Dominican Republic in 2002?
Your answer should be very brief. 4.84e+09. What is the difference between the Value added (constant 2005 US$) of Caribbean small states in 2000 and the Value added (constant 2005 US$) of Turkey in 2002?
Make the answer very short. -1.83e+11. What is the difference between the Value added (constant 2005 US$) of Upper middle income in 2000 and the Value added (constant 2005 US$) of Dominican Republic in 2002?
Provide a short and direct response. 2.35e+12. What is the difference between the Value added (constant 2005 US$) in Upper middle income in 2000 and the Value added (constant 2005 US$) in Turkey in 2002?
Provide a succinct answer. 2.16e+12. What is the difference between the Value added (constant 2005 US$) of Dominican Republic in 2000 and the Value added (constant 2005 US$) of Turkey in 2002?
Keep it short and to the point. -1.90e+11. What is the difference between the Value added (constant 2005 US$) in Caribbean small states in 2000 and the Value added (constant 2005 US$) in Upper middle income in 2003?
Ensure brevity in your answer.  -2.68e+12. What is the difference between the Value added (constant 2005 US$) in Caribbean small states in 2000 and the Value added (constant 2005 US$) in Dominican Republic in 2003?
Make the answer very short. 4.15e+09. What is the difference between the Value added (constant 2005 US$) in Caribbean small states in 2000 and the Value added (constant 2005 US$) in Turkey in 2003?
Your response must be concise. -1.91e+11. What is the difference between the Value added (constant 2005 US$) of Upper middle income in 2000 and the Value added (constant 2005 US$) of Dominican Republic in 2003?
Offer a very short reply. 2.35e+12. What is the difference between the Value added (constant 2005 US$) of Upper middle income in 2000 and the Value added (constant 2005 US$) of Turkey in 2003?
Provide a short and direct response. 2.15e+12. What is the difference between the Value added (constant 2005 US$) of Dominican Republic in 2000 and the Value added (constant 2005 US$) of Turkey in 2003?
Offer a terse response. -1.98e+11. What is the difference between the Value added (constant 2005 US$) in Caribbean small states in 2000 and the Value added (constant 2005 US$) in Upper middle income in 2004?
Your response must be concise. -2.88e+12. What is the difference between the Value added (constant 2005 US$) in Caribbean small states in 2000 and the Value added (constant 2005 US$) in Dominican Republic in 2004?
Your answer should be compact. 3.67e+09. What is the difference between the Value added (constant 2005 US$) in Caribbean small states in 2000 and the Value added (constant 2005 US$) in Turkey in 2004?
Ensure brevity in your answer.  -2.12e+11. What is the difference between the Value added (constant 2005 US$) in Upper middle income in 2000 and the Value added (constant 2005 US$) in Dominican Republic in 2004?
Your answer should be very brief. 2.35e+12. What is the difference between the Value added (constant 2005 US$) of Upper middle income in 2000 and the Value added (constant 2005 US$) of Turkey in 2004?
Your answer should be very brief. 2.13e+12. What is the difference between the Value added (constant 2005 US$) in Dominican Republic in 2000 and the Value added (constant 2005 US$) in Turkey in 2004?
Keep it short and to the point. -2.19e+11. What is the difference between the Value added (constant 2005 US$) of Caribbean small states in 2000 and the Value added (constant 2005 US$) of Upper middle income in 2005?
Your answer should be very brief. -3.09e+12. What is the difference between the Value added (constant 2005 US$) of Caribbean small states in 2000 and the Value added (constant 2005 US$) of Dominican Republic in 2005?
Keep it short and to the point. 2.07e+09. What is the difference between the Value added (constant 2005 US$) in Caribbean small states in 2000 and the Value added (constant 2005 US$) in Turkey in 2005?
Your answer should be compact. -2.32e+11. What is the difference between the Value added (constant 2005 US$) of Upper middle income in 2000 and the Value added (constant 2005 US$) of Dominican Republic in 2005?
Your answer should be very brief. 2.35e+12. What is the difference between the Value added (constant 2005 US$) of Upper middle income in 2000 and the Value added (constant 2005 US$) of Turkey in 2005?
Ensure brevity in your answer.  2.11e+12. What is the difference between the Value added (constant 2005 US$) in Dominican Republic in 2000 and the Value added (constant 2005 US$) in Turkey in 2005?
Provide a succinct answer. -2.39e+11. What is the difference between the Value added (constant 2005 US$) of Caribbean small states in 2001 and the Value added (constant 2005 US$) of Upper middle income in 2002?
Give a very brief answer. -2.57e+12. What is the difference between the Value added (constant 2005 US$) of Caribbean small states in 2001 and the Value added (constant 2005 US$) of Dominican Republic in 2002?
Give a very brief answer. 5.36e+09. What is the difference between the Value added (constant 2005 US$) in Caribbean small states in 2001 and the Value added (constant 2005 US$) in Turkey in 2002?
Make the answer very short. -1.82e+11. What is the difference between the Value added (constant 2005 US$) in Upper middle income in 2001 and the Value added (constant 2005 US$) in Dominican Republic in 2002?
Your answer should be very brief. 2.44e+12. What is the difference between the Value added (constant 2005 US$) of Upper middle income in 2001 and the Value added (constant 2005 US$) of Turkey in 2002?
Keep it short and to the point. 2.25e+12. What is the difference between the Value added (constant 2005 US$) in Dominican Republic in 2001 and the Value added (constant 2005 US$) in Turkey in 2002?
Your answer should be compact. -1.89e+11. What is the difference between the Value added (constant 2005 US$) in Caribbean small states in 2001 and the Value added (constant 2005 US$) in Upper middle income in 2003?
Keep it short and to the point. -2.68e+12. What is the difference between the Value added (constant 2005 US$) in Caribbean small states in 2001 and the Value added (constant 2005 US$) in Dominican Republic in 2003?
Provide a short and direct response. 4.68e+09. What is the difference between the Value added (constant 2005 US$) in Caribbean small states in 2001 and the Value added (constant 2005 US$) in Turkey in 2003?
Your answer should be compact. -1.91e+11. What is the difference between the Value added (constant 2005 US$) of Upper middle income in 2001 and the Value added (constant 2005 US$) of Dominican Republic in 2003?
Your response must be concise. 2.43e+12. What is the difference between the Value added (constant 2005 US$) of Upper middle income in 2001 and the Value added (constant 2005 US$) of Turkey in 2003?
Give a very brief answer. 2.24e+12. What is the difference between the Value added (constant 2005 US$) of Dominican Republic in 2001 and the Value added (constant 2005 US$) of Turkey in 2003?
Provide a succinct answer. -1.97e+11. What is the difference between the Value added (constant 2005 US$) in Caribbean small states in 2001 and the Value added (constant 2005 US$) in Upper middle income in 2004?
Ensure brevity in your answer.  -2.88e+12. What is the difference between the Value added (constant 2005 US$) in Caribbean small states in 2001 and the Value added (constant 2005 US$) in Dominican Republic in 2004?
Keep it short and to the point. 4.20e+09. What is the difference between the Value added (constant 2005 US$) of Caribbean small states in 2001 and the Value added (constant 2005 US$) of Turkey in 2004?
Your response must be concise. -2.12e+11. What is the difference between the Value added (constant 2005 US$) of Upper middle income in 2001 and the Value added (constant 2005 US$) of Dominican Republic in 2004?
Keep it short and to the point. 2.43e+12. What is the difference between the Value added (constant 2005 US$) of Upper middle income in 2001 and the Value added (constant 2005 US$) of Turkey in 2004?
Your answer should be compact. 2.22e+12. What is the difference between the Value added (constant 2005 US$) in Dominican Republic in 2001 and the Value added (constant 2005 US$) in Turkey in 2004?
Keep it short and to the point. -2.18e+11. What is the difference between the Value added (constant 2005 US$) of Caribbean small states in 2001 and the Value added (constant 2005 US$) of Upper middle income in 2005?
Offer a very short reply. -3.09e+12. What is the difference between the Value added (constant 2005 US$) in Caribbean small states in 2001 and the Value added (constant 2005 US$) in Dominican Republic in 2005?
Make the answer very short. 2.60e+09. What is the difference between the Value added (constant 2005 US$) in Caribbean small states in 2001 and the Value added (constant 2005 US$) in Turkey in 2005?
Your answer should be very brief. -2.32e+11. What is the difference between the Value added (constant 2005 US$) in Upper middle income in 2001 and the Value added (constant 2005 US$) in Dominican Republic in 2005?
Provide a succinct answer. 2.43e+12. What is the difference between the Value added (constant 2005 US$) in Upper middle income in 2001 and the Value added (constant 2005 US$) in Turkey in 2005?
Give a very brief answer. 2.20e+12. What is the difference between the Value added (constant 2005 US$) of Dominican Republic in 2001 and the Value added (constant 2005 US$) of Turkey in 2005?
Provide a short and direct response. -2.38e+11. What is the difference between the Value added (constant 2005 US$) in Caribbean small states in 2002 and the Value added (constant 2005 US$) in Upper middle income in 2003?
Ensure brevity in your answer.  -2.68e+12. What is the difference between the Value added (constant 2005 US$) of Caribbean small states in 2002 and the Value added (constant 2005 US$) of Dominican Republic in 2003?
Provide a short and direct response. 5.46e+09. What is the difference between the Value added (constant 2005 US$) of Caribbean small states in 2002 and the Value added (constant 2005 US$) of Turkey in 2003?
Give a very brief answer. -1.90e+11. What is the difference between the Value added (constant 2005 US$) in Upper middle income in 2002 and the Value added (constant 2005 US$) in Dominican Republic in 2003?
Your answer should be very brief. 2.57e+12. What is the difference between the Value added (constant 2005 US$) in Upper middle income in 2002 and the Value added (constant 2005 US$) in Turkey in 2003?
Keep it short and to the point. 2.37e+12. What is the difference between the Value added (constant 2005 US$) of Dominican Republic in 2002 and the Value added (constant 2005 US$) of Turkey in 2003?
Ensure brevity in your answer.  -1.96e+11. What is the difference between the Value added (constant 2005 US$) of Caribbean small states in 2002 and the Value added (constant 2005 US$) of Upper middle income in 2004?
Offer a very short reply. -2.88e+12. What is the difference between the Value added (constant 2005 US$) in Caribbean small states in 2002 and the Value added (constant 2005 US$) in Dominican Republic in 2004?
Offer a very short reply. 4.99e+09. What is the difference between the Value added (constant 2005 US$) of Caribbean small states in 2002 and the Value added (constant 2005 US$) of Turkey in 2004?
Give a very brief answer. -2.11e+11. What is the difference between the Value added (constant 2005 US$) in Upper middle income in 2002 and the Value added (constant 2005 US$) in Dominican Republic in 2004?
Your answer should be very brief. 2.57e+12. What is the difference between the Value added (constant 2005 US$) in Upper middle income in 2002 and the Value added (constant 2005 US$) in Turkey in 2004?
Offer a terse response. 2.35e+12. What is the difference between the Value added (constant 2005 US$) in Dominican Republic in 2002 and the Value added (constant 2005 US$) in Turkey in 2004?
Offer a terse response. -2.17e+11. What is the difference between the Value added (constant 2005 US$) in Caribbean small states in 2002 and the Value added (constant 2005 US$) in Upper middle income in 2005?
Offer a terse response. -3.09e+12. What is the difference between the Value added (constant 2005 US$) in Caribbean small states in 2002 and the Value added (constant 2005 US$) in Dominican Republic in 2005?
Ensure brevity in your answer.  3.38e+09. What is the difference between the Value added (constant 2005 US$) of Caribbean small states in 2002 and the Value added (constant 2005 US$) of Turkey in 2005?
Give a very brief answer. -2.31e+11. What is the difference between the Value added (constant 2005 US$) of Upper middle income in 2002 and the Value added (constant 2005 US$) of Dominican Republic in 2005?
Provide a succinct answer. 2.57e+12. What is the difference between the Value added (constant 2005 US$) of Upper middle income in 2002 and the Value added (constant 2005 US$) of Turkey in 2005?
Keep it short and to the point. 2.33e+12. What is the difference between the Value added (constant 2005 US$) in Dominican Republic in 2002 and the Value added (constant 2005 US$) in Turkey in 2005?
Make the answer very short. -2.37e+11. What is the difference between the Value added (constant 2005 US$) in Caribbean small states in 2003 and the Value added (constant 2005 US$) in Upper middle income in 2004?
Offer a very short reply. -2.88e+12. What is the difference between the Value added (constant 2005 US$) of Caribbean small states in 2003 and the Value added (constant 2005 US$) of Dominican Republic in 2004?
Give a very brief answer. 5.42e+09. What is the difference between the Value added (constant 2005 US$) in Caribbean small states in 2003 and the Value added (constant 2005 US$) in Turkey in 2004?
Ensure brevity in your answer.  -2.11e+11. What is the difference between the Value added (constant 2005 US$) of Upper middle income in 2003 and the Value added (constant 2005 US$) of Dominican Republic in 2004?
Your answer should be very brief. 2.69e+12. What is the difference between the Value added (constant 2005 US$) of Upper middle income in 2003 and the Value added (constant 2005 US$) of Turkey in 2004?
Ensure brevity in your answer.  2.47e+12. What is the difference between the Value added (constant 2005 US$) of Dominican Republic in 2003 and the Value added (constant 2005 US$) of Turkey in 2004?
Offer a terse response. -2.16e+11. What is the difference between the Value added (constant 2005 US$) of Caribbean small states in 2003 and the Value added (constant 2005 US$) of Upper middle income in 2005?
Offer a terse response. -3.09e+12. What is the difference between the Value added (constant 2005 US$) in Caribbean small states in 2003 and the Value added (constant 2005 US$) in Dominican Republic in 2005?
Offer a very short reply. 3.82e+09. What is the difference between the Value added (constant 2005 US$) of Caribbean small states in 2003 and the Value added (constant 2005 US$) of Turkey in 2005?
Offer a very short reply. -2.31e+11. What is the difference between the Value added (constant 2005 US$) in Upper middle income in 2003 and the Value added (constant 2005 US$) in Dominican Republic in 2005?
Provide a succinct answer. 2.69e+12. What is the difference between the Value added (constant 2005 US$) in Upper middle income in 2003 and the Value added (constant 2005 US$) in Turkey in 2005?
Your response must be concise. 2.45e+12. What is the difference between the Value added (constant 2005 US$) in Dominican Republic in 2003 and the Value added (constant 2005 US$) in Turkey in 2005?
Give a very brief answer. -2.37e+11. What is the difference between the Value added (constant 2005 US$) in Caribbean small states in 2004 and the Value added (constant 2005 US$) in Upper middle income in 2005?
Your answer should be very brief. -3.09e+12. What is the difference between the Value added (constant 2005 US$) in Caribbean small states in 2004 and the Value added (constant 2005 US$) in Dominican Republic in 2005?
Your response must be concise. 5.06e+09. What is the difference between the Value added (constant 2005 US$) in Caribbean small states in 2004 and the Value added (constant 2005 US$) in Turkey in 2005?
Provide a short and direct response. -2.29e+11. What is the difference between the Value added (constant 2005 US$) of Upper middle income in 2004 and the Value added (constant 2005 US$) of Dominican Republic in 2005?
Give a very brief answer. 2.88e+12. What is the difference between the Value added (constant 2005 US$) in Upper middle income in 2004 and the Value added (constant 2005 US$) in Turkey in 2005?
Keep it short and to the point. 2.65e+12. What is the difference between the Value added (constant 2005 US$) of Dominican Republic in 2004 and the Value added (constant 2005 US$) of Turkey in 2005?
Your response must be concise. -2.36e+11. What is the average Value added (constant 2005 US$) in Caribbean small states per year?
Offer a very short reply. 2.28e+1. What is the average Value added (constant 2005 US$) in Upper middle income per year?
Provide a short and direct response. 2.56e+12. What is the average Value added (constant 2005 US$) in Dominican Republic per year?
Keep it short and to the point. 1.63e+1. What is the average Value added (constant 2005 US$) of Turkey per year?
Offer a terse response. 2.09e+11. In the year 1998, what is the difference between the Value added (constant 2005 US$) in Caribbean small states and Value added (constant 2005 US$) in Upper middle income?
Offer a terse response. -2.13e+12. In the year 1998, what is the difference between the Value added (constant 2005 US$) of Caribbean small states and Value added (constant 2005 US$) of Dominican Republic?
Your answer should be compact. 6.99e+09. In the year 1998, what is the difference between the Value added (constant 2005 US$) of Caribbean small states and Value added (constant 2005 US$) of Turkey?
Provide a short and direct response. -1.67e+11. In the year 1998, what is the difference between the Value added (constant 2005 US$) of Upper middle income and Value added (constant 2005 US$) of Dominican Republic?
Offer a very short reply. 2.14e+12. In the year 1998, what is the difference between the Value added (constant 2005 US$) in Upper middle income and Value added (constant 2005 US$) in Turkey?
Keep it short and to the point. 1.96e+12. In the year 1998, what is the difference between the Value added (constant 2005 US$) of Dominican Republic and Value added (constant 2005 US$) of Turkey?
Ensure brevity in your answer.  -1.74e+11. In the year 1999, what is the difference between the Value added (constant 2005 US$) of Caribbean small states and Value added (constant 2005 US$) of Upper middle income?
Make the answer very short. -2.21e+12. In the year 1999, what is the difference between the Value added (constant 2005 US$) of Caribbean small states and Value added (constant 2005 US$) of Dominican Republic?
Provide a succinct answer. 6.89e+09. In the year 1999, what is the difference between the Value added (constant 2005 US$) in Caribbean small states and Value added (constant 2005 US$) in Turkey?
Give a very brief answer. -1.64e+11. In the year 1999, what is the difference between the Value added (constant 2005 US$) in Upper middle income and Value added (constant 2005 US$) in Dominican Republic?
Your response must be concise. 2.21e+12. In the year 1999, what is the difference between the Value added (constant 2005 US$) of Upper middle income and Value added (constant 2005 US$) of Turkey?
Keep it short and to the point. 2.04e+12. In the year 1999, what is the difference between the Value added (constant 2005 US$) in Dominican Republic and Value added (constant 2005 US$) in Turkey?
Your answer should be compact. -1.71e+11. In the year 2000, what is the difference between the Value added (constant 2005 US$) in Caribbean small states and Value added (constant 2005 US$) in Upper middle income?
Offer a very short reply. -2.35e+12. In the year 2000, what is the difference between the Value added (constant 2005 US$) of Caribbean small states and Value added (constant 2005 US$) of Dominican Republic?
Make the answer very short. 6.89e+09. In the year 2000, what is the difference between the Value added (constant 2005 US$) in Caribbean small states and Value added (constant 2005 US$) in Turkey?
Keep it short and to the point. -1.76e+11. In the year 2000, what is the difference between the Value added (constant 2005 US$) in Upper middle income and Value added (constant 2005 US$) in Dominican Republic?
Your answer should be compact. 2.35e+12. In the year 2000, what is the difference between the Value added (constant 2005 US$) of Upper middle income and Value added (constant 2005 US$) of Turkey?
Make the answer very short. 2.17e+12. In the year 2000, what is the difference between the Value added (constant 2005 US$) in Dominican Republic and Value added (constant 2005 US$) in Turkey?
Make the answer very short. -1.83e+11. In the year 2001, what is the difference between the Value added (constant 2005 US$) in Caribbean small states and Value added (constant 2005 US$) in Upper middle income?
Give a very brief answer. -2.43e+12. In the year 2001, what is the difference between the Value added (constant 2005 US$) of Caribbean small states and Value added (constant 2005 US$) of Dominican Republic?
Your answer should be compact. 6.54e+09. In the year 2001, what is the difference between the Value added (constant 2005 US$) of Caribbean small states and Value added (constant 2005 US$) of Turkey?
Provide a short and direct response. -1.73e+11. In the year 2001, what is the difference between the Value added (constant 2005 US$) of Upper middle income and Value added (constant 2005 US$) of Dominican Republic?
Your answer should be compact. 2.44e+12. In the year 2001, what is the difference between the Value added (constant 2005 US$) of Upper middle income and Value added (constant 2005 US$) of Turkey?
Your answer should be compact. 2.26e+12. In the year 2001, what is the difference between the Value added (constant 2005 US$) of Dominican Republic and Value added (constant 2005 US$) of Turkey?
Keep it short and to the point. -1.80e+11. In the year 2002, what is the difference between the Value added (constant 2005 US$) of Caribbean small states and Value added (constant 2005 US$) of Upper middle income?
Provide a succinct answer. -2.56e+12. In the year 2002, what is the difference between the Value added (constant 2005 US$) in Caribbean small states and Value added (constant 2005 US$) in Dominican Republic?
Your response must be concise. 6.15e+09. In the year 2002, what is the difference between the Value added (constant 2005 US$) of Caribbean small states and Value added (constant 2005 US$) of Turkey?
Offer a very short reply. -1.82e+11. In the year 2002, what is the difference between the Value added (constant 2005 US$) in Upper middle income and Value added (constant 2005 US$) in Dominican Republic?
Offer a very short reply. 2.57e+12. In the year 2002, what is the difference between the Value added (constant 2005 US$) in Upper middle income and Value added (constant 2005 US$) in Turkey?
Provide a short and direct response. 2.38e+12. In the year 2002, what is the difference between the Value added (constant 2005 US$) in Dominican Republic and Value added (constant 2005 US$) in Turkey?
Provide a short and direct response. -1.88e+11. In the year 2003, what is the difference between the Value added (constant 2005 US$) of Caribbean small states and Value added (constant 2005 US$) of Upper middle income?
Ensure brevity in your answer.  -2.68e+12. In the year 2003, what is the difference between the Value added (constant 2005 US$) in Caribbean small states and Value added (constant 2005 US$) in Dominican Republic?
Offer a terse response. 5.90e+09. In the year 2003, what is the difference between the Value added (constant 2005 US$) in Caribbean small states and Value added (constant 2005 US$) in Turkey?
Offer a terse response. -1.90e+11. In the year 2003, what is the difference between the Value added (constant 2005 US$) in Upper middle income and Value added (constant 2005 US$) in Dominican Republic?
Provide a short and direct response. 2.69e+12. In the year 2003, what is the difference between the Value added (constant 2005 US$) in Upper middle income and Value added (constant 2005 US$) in Turkey?
Your response must be concise. 2.49e+12. In the year 2003, what is the difference between the Value added (constant 2005 US$) in Dominican Republic and Value added (constant 2005 US$) in Turkey?
Your answer should be compact. -1.96e+11. In the year 2004, what is the difference between the Value added (constant 2005 US$) of Caribbean small states and Value added (constant 2005 US$) of Upper middle income?
Your response must be concise. -2.88e+12. In the year 2004, what is the difference between the Value added (constant 2005 US$) of Caribbean small states and Value added (constant 2005 US$) of Dominican Republic?
Offer a very short reply. 6.67e+09. In the year 2004, what is the difference between the Value added (constant 2005 US$) in Caribbean small states and Value added (constant 2005 US$) in Turkey?
Give a very brief answer. -2.09e+11. In the year 2004, what is the difference between the Value added (constant 2005 US$) in Upper middle income and Value added (constant 2005 US$) in Dominican Republic?
Provide a succinct answer. 2.88e+12. In the year 2004, what is the difference between the Value added (constant 2005 US$) in Upper middle income and Value added (constant 2005 US$) in Turkey?
Ensure brevity in your answer.  2.67e+12. In the year 2004, what is the difference between the Value added (constant 2005 US$) in Dominican Republic and Value added (constant 2005 US$) in Turkey?
Your answer should be compact. -2.16e+11. In the year 2005, what is the difference between the Value added (constant 2005 US$) in Caribbean small states and Value added (constant 2005 US$) in Upper middle income?
Provide a short and direct response. -3.09e+12. In the year 2005, what is the difference between the Value added (constant 2005 US$) of Caribbean small states and Value added (constant 2005 US$) of Dominican Republic?
Make the answer very short. 5.60e+09. In the year 2005, what is the difference between the Value added (constant 2005 US$) of Caribbean small states and Value added (constant 2005 US$) of Turkey?
Ensure brevity in your answer.  -2.29e+11. In the year 2005, what is the difference between the Value added (constant 2005 US$) in Upper middle income and Value added (constant 2005 US$) in Dominican Republic?
Your answer should be compact. 3.10e+12. In the year 2005, what is the difference between the Value added (constant 2005 US$) of Upper middle income and Value added (constant 2005 US$) of Turkey?
Ensure brevity in your answer.  2.86e+12. In the year 2005, what is the difference between the Value added (constant 2005 US$) of Dominican Republic and Value added (constant 2005 US$) of Turkey?
Keep it short and to the point. -2.34e+11. What is the ratio of the Value added (constant 2005 US$) in Caribbean small states in 1998 to that in 1999?
Keep it short and to the point. 0.96. What is the ratio of the Value added (constant 2005 US$) of Upper middle income in 1998 to that in 1999?
Offer a terse response. 0.96. What is the ratio of the Value added (constant 2005 US$) in Dominican Republic in 1998 to that in 1999?
Give a very brief answer. 0.94. What is the ratio of the Value added (constant 2005 US$) of Caribbean small states in 1998 to that in 2000?
Make the answer very short. 0.93. What is the ratio of the Value added (constant 2005 US$) in Upper middle income in 1998 to that in 2000?
Ensure brevity in your answer.  0.91. What is the ratio of the Value added (constant 2005 US$) in Dominican Republic in 1998 to that in 2000?
Offer a terse response. 0.89. What is the ratio of the Value added (constant 2005 US$) of Turkey in 1998 to that in 2000?
Keep it short and to the point. 0.95. What is the ratio of the Value added (constant 2005 US$) of Caribbean small states in 1998 to that in 2001?
Give a very brief answer. 0.91. What is the ratio of the Value added (constant 2005 US$) of Upper middle income in 1998 to that in 2001?
Provide a succinct answer. 0.88. What is the ratio of the Value added (constant 2005 US$) in Dominican Republic in 1998 to that in 2001?
Make the answer very short. 0.84. What is the ratio of the Value added (constant 2005 US$) of Turkey in 1998 to that in 2001?
Ensure brevity in your answer.  0.96. What is the ratio of the Value added (constant 2005 US$) in Caribbean small states in 1998 to that in 2002?
Ensure brevity in your answer.  0.88. What is the ratio of the Value added (constant 2005 US$) of Upper middle income in 1998 to that in 2002?
Your answer should be very brief. 0.83. What is the ratio of the Value added (constant 2005 US$) of Dominican Republic in 1998 to that in 2002?
Your response must be concise. 0.78. What is the ratio of the Value added (constant 2005 US$) of Turkey in 1998 to that in 2002?
Make the answer very short. 0.92. What is the ratio of the Value added (constant 2005 US$) of Caribbean small states in 1998 to that in 2003?
Provide a succinct answer. 0.86. What is the ratio of the Value added (constant 2005 US$) of Upper middle income in 1998 to that in 2003?
Provide a short and direct response. 0.79. What is the ratio of the Value added (constant 2005 US$) in Dominican Republic in 1998 to that in 2003?
Your response must be concise. 0.75. What is the ratio of the Value added (constant 2005 US$) of Turkey in 1998 to that in 2003?
Provide a short and direct response. 0.88. What is the ratio of the Value added (constant 2005 US$) of Caribbean small states in 1998 to that in 2004?
Your response must be concise. 0.82. What is the ratio of the Value added (constant 2005 US$) in Upper middle income in 1998 to that in 2004?
Your answer should be very brief. 0.74. What is the ratio of the Value added (constant 2005 US$) in Dominican Republic in 1998 to that in 2004?
Keep it short and to the point. 0.73. What is the ratio of the Value added (constant 2005 US$) in Turkey in 1998 to that in 2004?
Provide a short and direct response. 0.8. What is the ratio of the Value added (constant 2005 US$) in Caribbean small states in 1998 to that in 2005?
Offer a very short reply. 0.8. What is the ratio of the Value added (constant 2005 US$) of Upper middle income in 1998 to that in 2005?
Provide a succinct answer. 0.69. What is the ratio of the Value added (constant 2005 US$) of Dominican Republic in 1998 to that in 2005?
Make the answer very short. 0.67. What is the ratio of the Value added (constant 2005 US$) in Turkey in 1998 to that in 2005?
Your answer should be compact. 0.74. What is the ratio of the Value added (constant 2005 US$) of Caribbean small states in 1999 to that in 2000?
Offer a terse response. 0.97. What is the ratio of the Value added (constant 2005 US$) of Upper middle income in 1999 to that in 2000?
Make the answer very short. 0.94. What is the ratio of the Value added (constant 2005 US$) of Dominican Republic in 1999 to that in 2000?
Your response must be concise. 0.95. What is the ratio of the Value added (constant 2005 US$) in Turkey in 1999 to that in 2000?
Your answer should be compact. 0.94. What is the ratio of the Value added (constant 2005 US$) in Caribbean small states in 1999 to that in 2001?
Offer a terse response. 0.94. What is the ratio of the Value added (constant 2005 US$) in Upper middle income in 1999 to that in 2001?
Make the answer very short. 0.91. What is the ratio of the Value added (constant 2005 US$) of Dominican Republic in 1999 to that in 2001?
Offer a very short reply. 0.9. What is the ratio of the Value added (constant 2005 US$) in Turkey in 1999 to that in 2001?
Your response must be concise. 0.95. What is the ratio of the Value added (constant 2005 US$) of Caribbean small states in 1999 to that in 2002?
Provide a succinct answer. 0.91. What is the ratio of the Value added (constant 2005 US$) in Upper middle income in 1999 to that in 2002?
Provide a short and direct response. 0.86. What is the ratio of the Value added (constant 2005 US$) of Dominican Republic in 1999 to that in 2002?
Your response must be concise. 0.83. What is the ratio of the Value added (constant 2005 US$) of Turkey in 1999 to that in 2002?
Offer a very short reply. 0.9. What is the ratio of the Value added (constant 2005 US$) in Caribbean small states in 1999 to that in 2003?
Offer a very short reply. 0.89. What is the ratio of the Value added (constant 2005 US$) of Upper middle income in 1999 to that in 2003?
Ensure brevity in your answer.  0.82. What is the ratio of the Value added (constant 2005 US$) in Dominican Republic in 1999 to that in 2003?
Your answer should be very brief. 0.8. What is the ratio of the Value added (constant 2005 US$) in Turkey in 1999 to that in 2003?
Offer a very short reply. 0.87. What is the ratio of the Value added (constant 2005 US$) in Caribbean small states in 1999 to that in 2004?
Keep it short and to the point. 0.85. What is the ratio of the Value added (constant 2005 US$) in Upper middle income in 1999 to that in 2004?
Provide a short and direct response. 0.77. What is the ratio of the Value added (constant 2005 US$) in Dominican Republic in 1999 to that in 2004?
Provide a short and direct response. 0.78. What is the ratio of the Value added (constant 2005 US$) of Turkey in 1999 to that in 2004?
Offer a very short reply. 0.79. What is the ratio of the Value added (constant 2005 US$) of Caribbean small states in 1999 to that in 2005?
Give a very brief answer. 0.83. What is the ratio of the Value added (constant 2005 US$) in Upper middle income in 1999 to that in 2005?
Your response must be concise. 0.72. What is the ratio of the Value added (constant 2005 US$) of Dominican Republic in 1999 to that in 2005?
Provide a succinct answer. 0.72. What is the ratio of the Value added (constant 2005 US$) in Turkey in 1999 to that in 2005?
Provide a succinct answer. 0.73. What is the ratio of the Value added (constant 2005 US$) of Caribbean small states in 2000 to that in 2001?
Provide a short and direct response. 0.98. What is the ratio of the Value added (constant 2005 US$) of Upper middle income in 2000 to that in 2001?
Make the answer very short. 0.97. What is the ratio of the Value added (constant 2005 US$) in Dominican Republic in 2000 to that in 2001?
Provide a succinct answer. 0.94. What is the ratio of the Value added (constant 2005 US$) in Turkey in 2000 to that in 2001?
Your response must be concise. 1.01. What is the ratio of the Value added (constant 2005 US$) in Caribbean small states in 2000 to that in 2002?
Give a very brief answer. 0.94. What is the ratio of the Value added (constant 2005 US$) in Upper middle income in 2000 to that in 2002?
Provide a short and direct response. 0.91. What is the ratio of the Value added (constant 2005 US$) of Dominican Republic in 2000 to that in 2002?
Offer a very short reply. 0.88. What is the ratio of the Value added (constant 2005 US$) in Turkey in 2000 to that in 2002?
Offer a very short reply. 0.96. What is the ratio of the Value added (constant 2005 US$) of Caribbean small states in 2000 to that in 2003?
Ensure brevity in your answer.  0.93. What is the ratio of the Value added (constant 2005 US$) of Upper middle income in 2000 to that in 2003?
Ensure brevity in your answer.  0.87. What is the ratio of the Value added (constant 2005 US$) in Dominican Republic in 2000 to that in 2003?
Provide a succinct answer. 0.84. What is the ratio of the Value added (constant 2005 US$) of Turkey in 2000 to that in 2003?
Provide a succinct answer. 0.93. What is the ratio of the Value added (constant 2005 US$) of Caribbean small states in 2000 to that in 2004?
Give a very brief answer. 0.88. What is the ratio of the Value added (constant 2005 US$) in Upper middle income in 2000 to that in 2004?
Your answer should be very brief. 0.82. What is the ratio of the Value added (constant 2005 US$) of Dominican Republic in 2000 to that in 2004?
Your response must be concise. 0.82. What is the ratio of the Value added (constant 2005 US$) in Turkey in 2000 to that in 2004?
Keep it short and to the point. 0.84. What is the ratio of the Value added (constant 2005 US$) of Caribbean small states in 2000 to that in 2005?
Offer a terse response. 0.86. What is the ratio of the Value added (constant 2005 US$) of Upper middle income in 2000 to that in 2005?
Keep it short and to the point. 0.76. What is the ratio of the Value added (constant 2005 US$) in Dominican Republic in 2000 to that in 2005?
Keep it short and to the point. 0.76. What is the ratio of the Value added (constant 2005 US$) in Turkey in 2000 to that in 2005?
Your answer should be very brief. 0.78. What is the ratio of the Value added (constant 2005 US$) in Caribbean small states in 2001 to that in 2002?
Provide a succinct answer. 0.97. What is the ratio of the Value added (constant 2005 US$) in Upper middle income in 2001 to that in 2002?
Keep it short and to the point. 0.95. What is the ratio of the Value added (constant 2005 US$) of Dominican Republic in 2001 to that in 2002?
Keep it short and to the point. 0.93. What is the ratio of the Value added (constant 2005 US$) in Turkey in 2001 to that in 2002?
Your answer should be very brief. 0.96. What is the ratio of the Value added (constant 2005 US$) of Caribbean small states in 2001 to that in 2003?
Your response must be concise. 0.95. What is the ratio of the Value added (constant 2005 US$) in Upper middle income in 2001 to that in 2003?
Your answer should be compact. 0.91. What is the ratio of the Value added (constant 2005 US$) in Dominican Republic in 2001 to that in 2003?
Your answer should be very brief. 0.89. What is the ratio of the Value added (constant 2005 US$) of Turkey in 2001 to that in 2003?
Offer a terse response. 0.92. What is the ratio of the Value added (constant 2005 US$) in Caribbean small states in 2001 to that in 2004?
Give a very brief answer. 0.9. What is the ratio of the Value added (constant 2005 US$) of Upper middle income in 2001 to that in 2004?
Provide a short and direct response. 0.84. What is the ratio of the Value added (constant 2005 US$) of Dominican Republic in 2001 to that in 2004?
Provide a succinct answer. 0.87. What is the ratio of the Value added (constant 2005 US$) of Turkey in 2001 to that in 2004?
Offer a terse response. 0.84. What is the ratio of the Value added (constant 2005 US$) in Caribbean small states in 2001 to that in 2005?
Provide a short and direct response. 0.88. What is the ratio of the Value added (constant 2005 US$) in Upper middle income in 2001 to that in 2005?
Ensure brevity in your answer.  0.79. What is the ratio of the Value added (constant 2005 US$) of Dominican Republic in 2001 to that in 2005?
Your response must be concise. 0.8. What is the ratio of the Value added (constant 2005 US$) in Turkey in 2001 to that in 2005?
Offer a terse response. 0.77. What is the ratio of the Value added (constant 2005 US$) in Caribbean small states in 2002 to that in 2003?
Offer a terse response. 0.98. What is the ratio of the Value added (constant 2005 US$) in Upper middle income in 2002 to that in 2003?
Give a very brief answer. 0.96. What is the ratio of the Value added (constant 2005 US$) in Dominican Republic in 2002 to that in 2003?
Ensure brevity in your answer.  0.96. What is the ratio of the Value added (constant 2005 US$) of Turkey in 2002 to that in 2003?
Your response must be concise. 0.96. What is the ratio of the Value added (constant 2005 US$) in Caribbean small states in 2002 to that in 2004?
Your answer should be very brief. 0.93. What is the ratio of the Value added (constant 2005 US$) of Upper middle income in 2002 to that in 2004?
Your answer should be very brief. 0.89. What is the ratio of the Value added (constant 2005 US$) in Dominican Republic in 2002 to that in 2004?
Your response must be concise. 0.94. What is the ratio of the Value added (constant 2005 US$) in Turkey in 2002 to that in 2004?
Your answer should be compact. 0.87. What is the ratio of the Value added (constant 2005 US$) of Caribbean small states in 2002 to that in 2005?
Your answer should be very brief. 0.91. What is the ratio of the Value added (constant 2005 US$) in Upper middle income in 2002 to that in 2005?
Offer a terse response. 0.83. What is the ratio of the Value added (constant 2005 US$) of Dominican Republic in 2002 to that in 2005?
Your answer should be very brief. 0.86. What is the ratio of the Value added (constant 2005 US$) of Turkey in 2002 to that in 2005?
Offer a very short reply. 0.81. What is the ratio of the Value added (constant 2005 US$) in Upper middle income in 2003 to that in 2004?
Make the answer very short. 0.93. What is the ratio of the Value added (constant 2005 US$) of Dominican Republic in 2003 to that in 2004?
Offer a very short reply. 0.97. What is the ratio of the Value added (constant 2005 US$) in Turkey in 2003 to that in 2004?
Ensure brevity in your answer.  0.91. What is the ratio of the Value added (constant 2005 US$) in Caribbean small states in 2003 to that in 2005?
Provide a succinct answer. 0.93. What is the ratio of the Value added (constant 2005 US$) in Upper middle income in 2003 to that in 2005?
Your answer should be compact. 0.87. What is the ratio of the Value added (constant 2005 US$) of Dominican Republic in 2003 to that in 2005?
Provide a short and direct response. 0.89. What is the ratio of the Value added (constant 2005 US$) in Turkey in 2003 to that in 2005?
Offer a very short reply. 0.84. What is the ratio of the Value added (constant 2005 US$) of Upper middle income in 2004 to that in 2005?
Provide a short and direct response. 0.93. What is the ratio of the Value added (constant 2005 US$) in Dominican Republic in 2004 to that in 2005?
Your answer should be compact. 0.92. What is the ratio of the Value added (constant 2005 US$) of Turkey in 2004 to that in 2005?
Your response must be concise. 0.92. What is the difference between the highest and the second highest Value added (constant 2005 US$) of Caribbean small states?
Offer a terse response. 5.33e+08. What is the difference between the highest and the second highest Value added (constant 2005 US$) of Upper middle income?
Provide a succinct answer. 2.14e+11. What is the difference between the highest and the second highest Value added (constant 2005 US$) in Dominican Republic?
Offer a very short reply. 1.60e+09. What is the difference between the highest and the second highest Value added (constant 2005 US$) of Turkey?
Your answer should be compact. 2.01e+1. What is the difference between the highest and the lowest Value added (constant 2005 US$) of Caribbean small states?
Provide a succinct answer. 5.08e+09. What is the difference between the highest and the lowest Value added (constant 2005 US$) in Upper middle income?
Ensure brevity in your answer.  9.66e+11. What is the difference between the highest and the lowest Value added (constant 2005 US$) of Dominican Republic?
Provide a succinct answer. 6.48e+09. What is the difference between the highest and the lowest Value added (constant 2005 US$) of Turkey?
Give a very brief answer. 6.90e+1. 